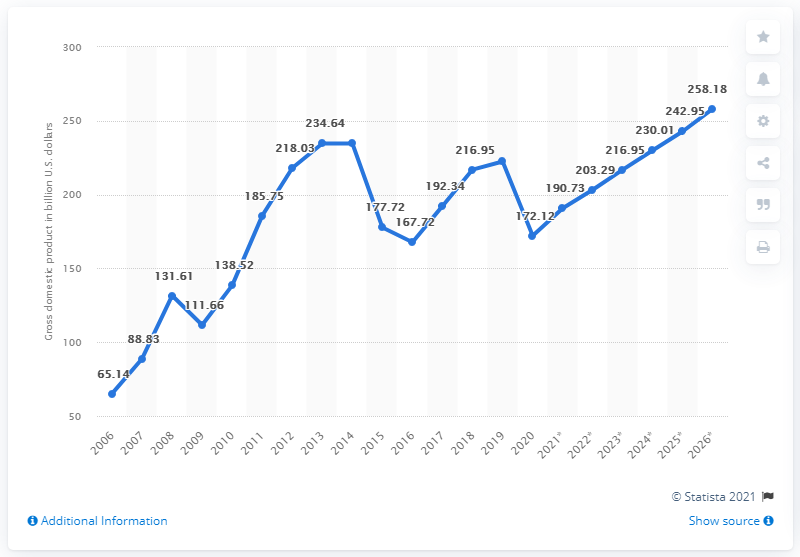How does the economic projection for Iraq look, based on the graph? Based on the graph, the projection for Iraq's economy seems optimistic, with an expected recovery and growth after 2020. Predictions show a rising trend through 2021 to 2026, suggesting a resilient economy that's anticipated to overcome the temporary setbacks experienced in 2020. 